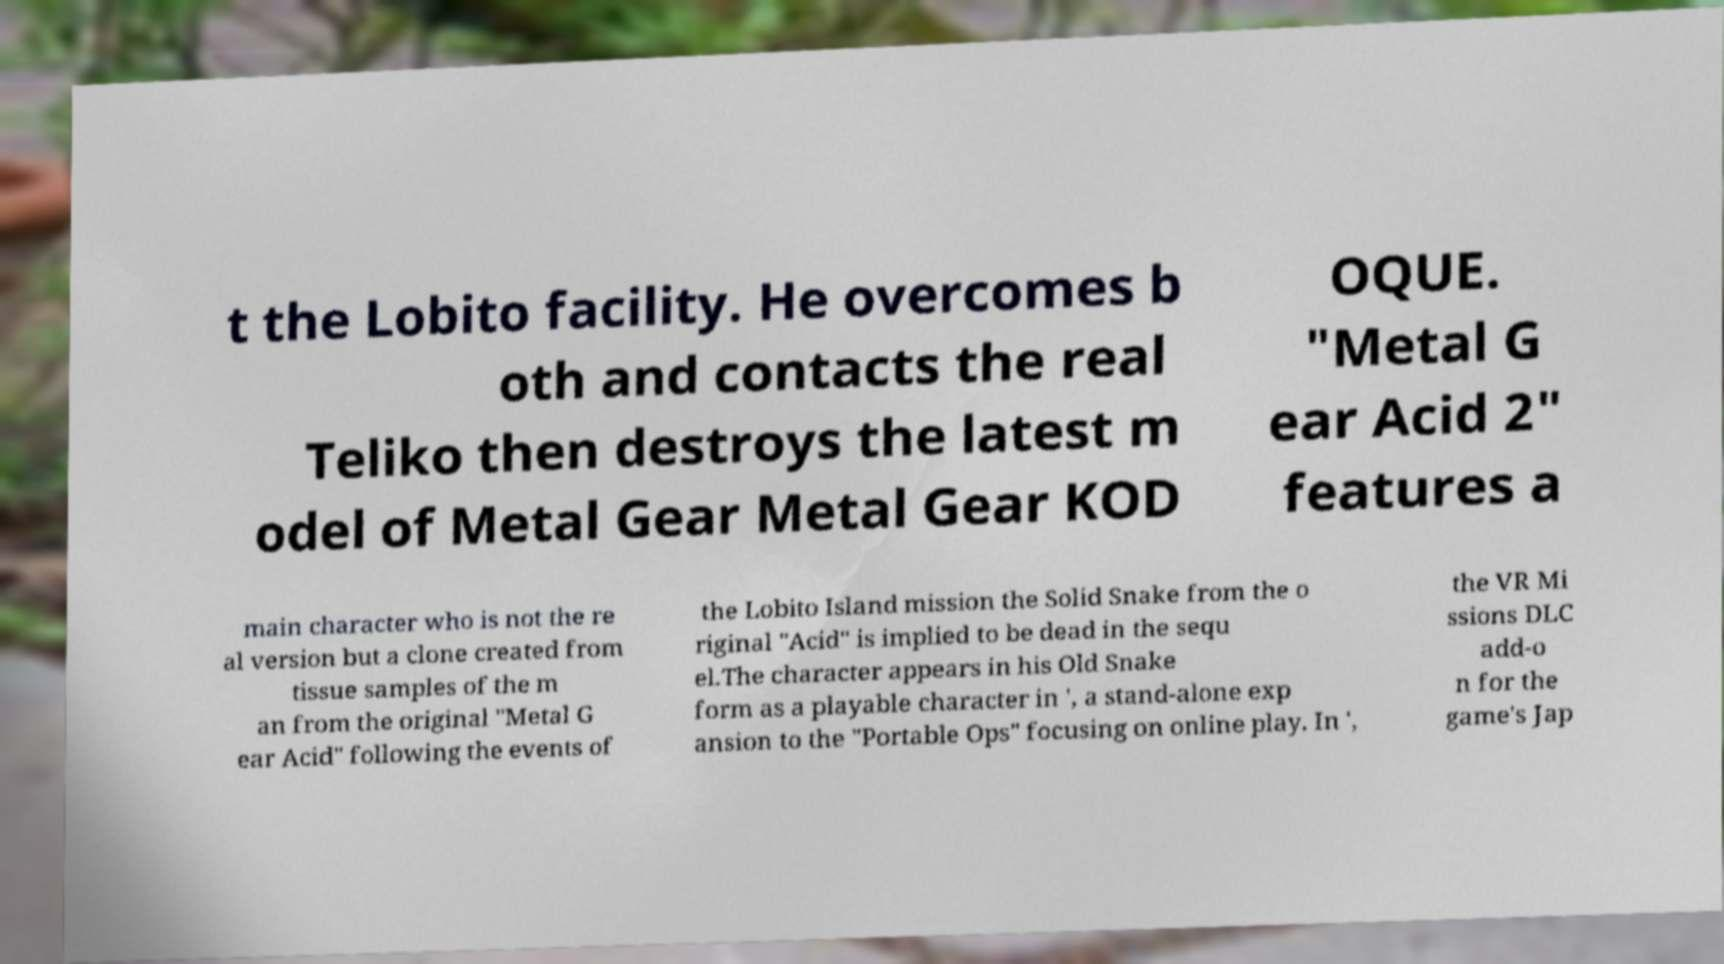What messages or text are displayed in this image? I need them in a readable, typed format. t the Lobito facility. He overcomes b oth and contacts the real Teliko then destroys the latest m odel of Metal Gear Metal Gear KOD OQUE. "Metal G ear Acid 2" features a main character who is not the re al version but a clone created from tissue samples of the m an from the original "Metal G ear Acid" following the events of the Lobito Island mission the Solid Snake from the o riginal "Acid" is implied to be dead in the sequ el.The character appears in his Old Snake form as a playable character in ', a stand-alone exp ansion to the "Portable Ops" focusing on online play. In ', the VR Mi ssions DLC add-o n for the game's Jap 